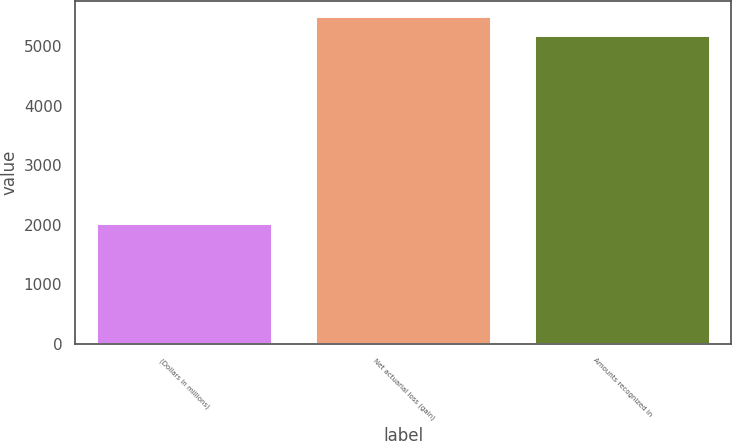Convert chart. <chart><loc_0><loc_0><loc_500><loc_500><bar_chart><fcel>(Dollars in millions)<fcel>Net actuarial loss (gain)<fcel>Amounts recognized in<nl><fcel>2017<fcel>5480.5<fcel>5165<nl></chart> 